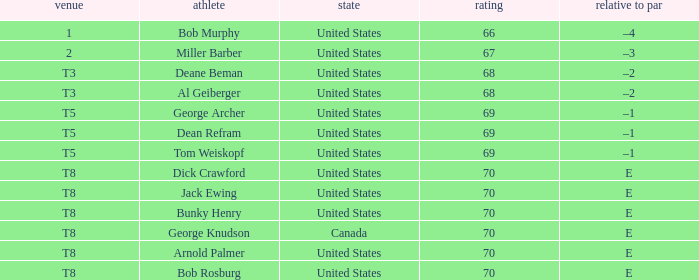When bunky henry achieved the t8 ranking, what was his to par? E. 